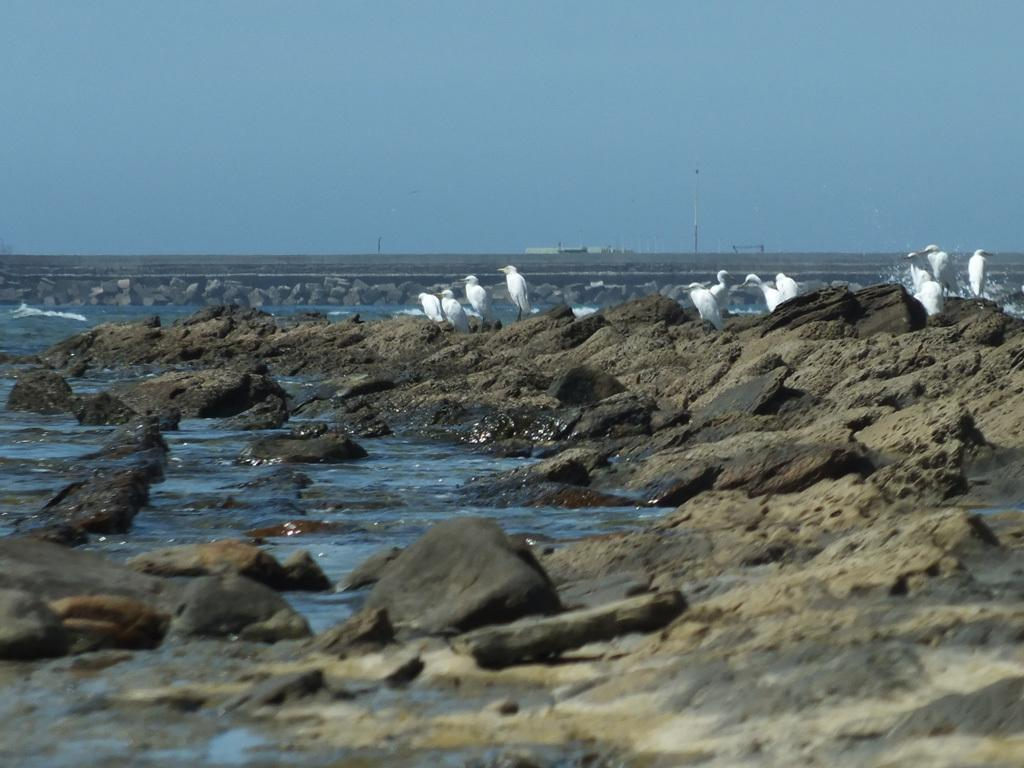What is the main subject of the image? The main subject of the image is birds on a rock. What can be seen in the background of the image? There is water visible in the image, and the sky is blue. What color are the birds in the image? The birds are white in color. What type of wax is being used by the birds to build their nests in the image? There is no indication in the image that the birds are building nests or using wax for any purpose. 